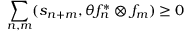<formula> <loc_0><loc_0><loc_500><loc_500>\sum _ { n , m } ( s _ { n + m } , \theta f _ { n } ^ { \ast } \otimes f _ { m } ) \geq 0</formula> 